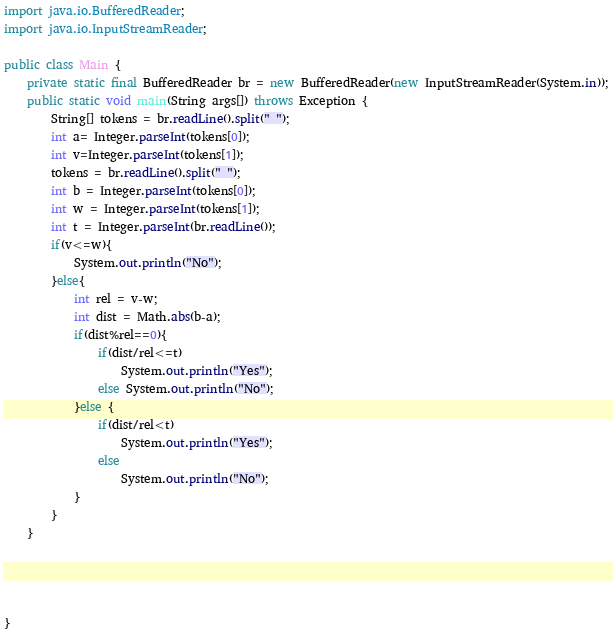Convert code to text. <code><loc_0><loc_0><loc_500><loc_500><_Java_>import java.io.BufferedReader;
import java.io.InputStreamReader;

public class Main {
    private static final BufferedReader br = new BufferedReader(new InputStreamReader(System.in));
    public static void main(String args[]) throws Exception {
        String[] tokens = br.readLine().split(" ");
        int a= Integer.parseInt(tokens[0]);
        int v=Integer.parseInt(tokens[1]);
        tokens = br.readLine().split(" ");
        int b = Integer.parseInt(tokens[0]);
        int w = Integer.parseInt(tokens[1]);
        int t = Integer.parseInt(br.readLine());
        if(v<=w){
            System.out.println("No");
        }else{
            int rel = v-w;
            int dist = Math.abs(b-a);
            if(dist%rel==0){
                if(dist/rel<=t)
                    System.out.println("Yes");
                else System.out.println("No");
            }else {
                if(dist/rel<t)
                    System.out.println("Yes");
                else
                    System.out.println("No");
            }
        }
    }




}</code> 